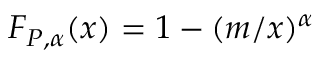Convert formula to latex. <formula><loc_0><loc_0><loc_500><loc_500>F _ { P , \alpha } ( x ) = 1 - ( m / x ) ^ { \alpha }</formula> 